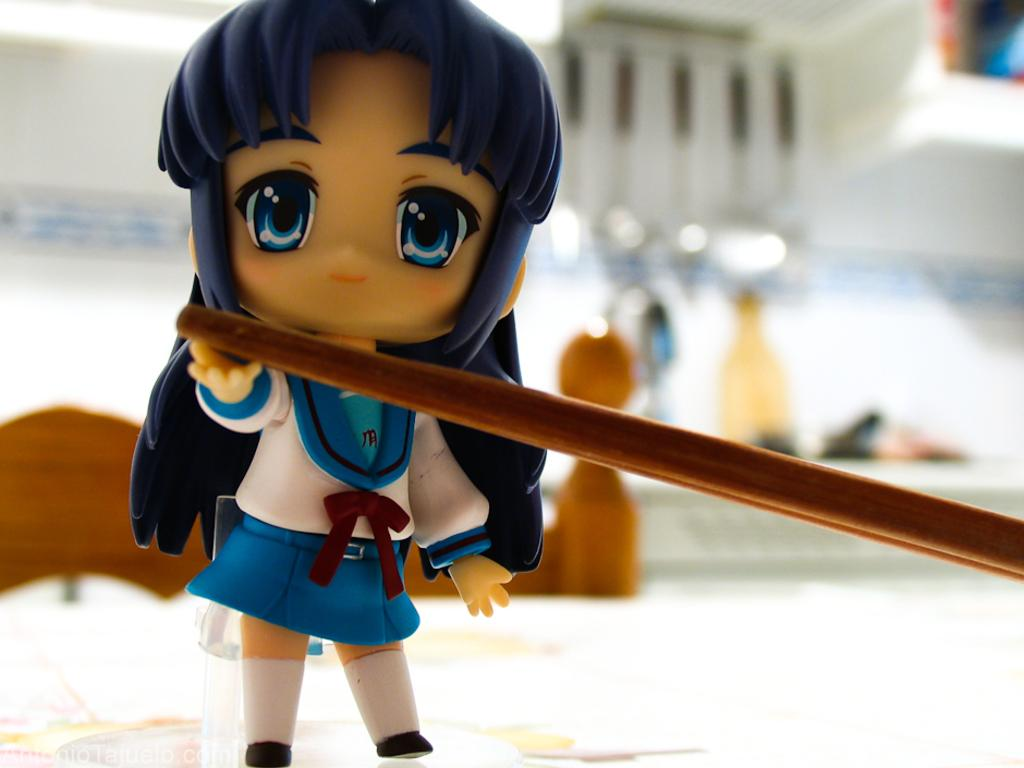What type of toy is in the image? There is a girl toy in the image. What is the surface on which the toy is placed? The girl toy is placed on a white surface. Can you describe the background of the image? The background of the image is blurred. Are there any other objects visible in the image? Yes, there are a few other objects in the image. How many ladybugs can be seen on the girl toy in the image? There are no ladybugs present on the girl toy or in the image. What time of day is depicted in the image? The time of day cannot be determined from the image, as there are no clues or indicators of time present. 